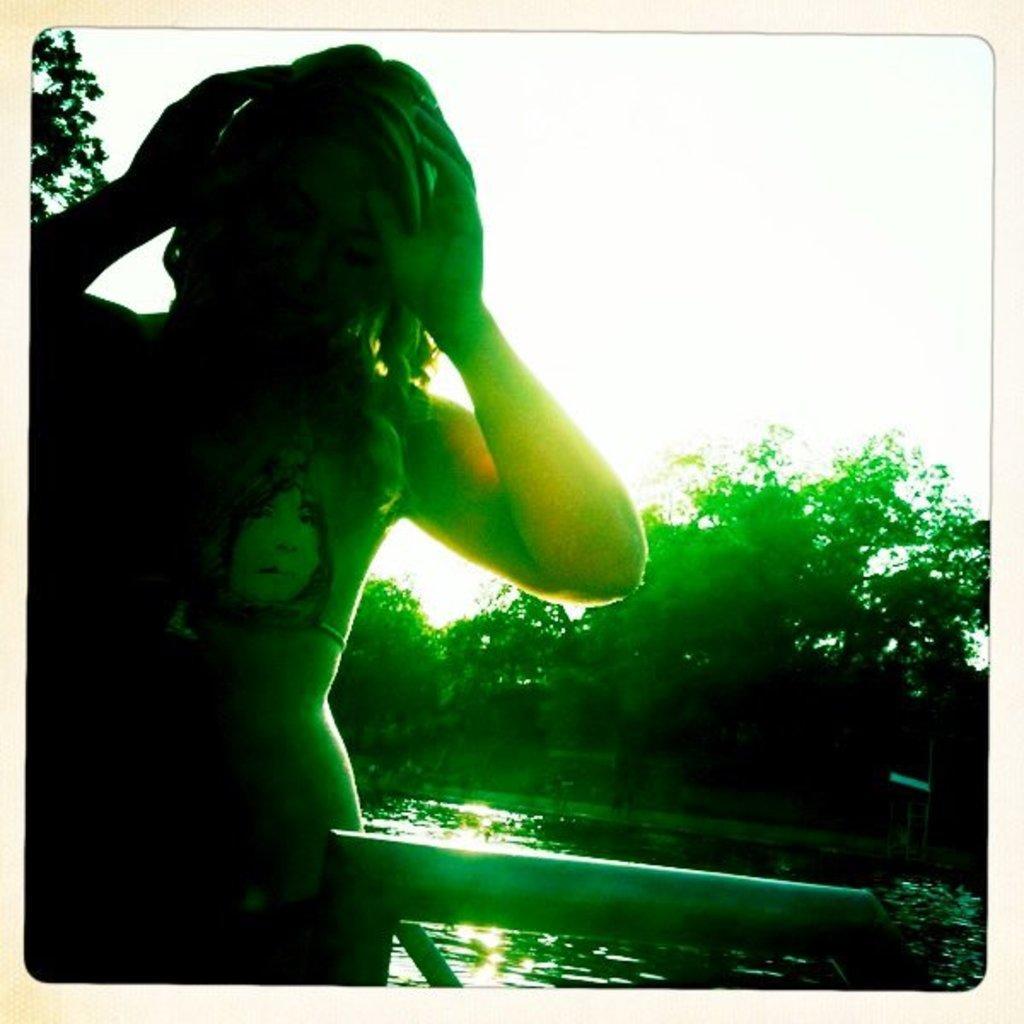Describe this image in one or two sentences. In this image we can see a girl standing at the pond. In the background we can see water, trees and sky. 